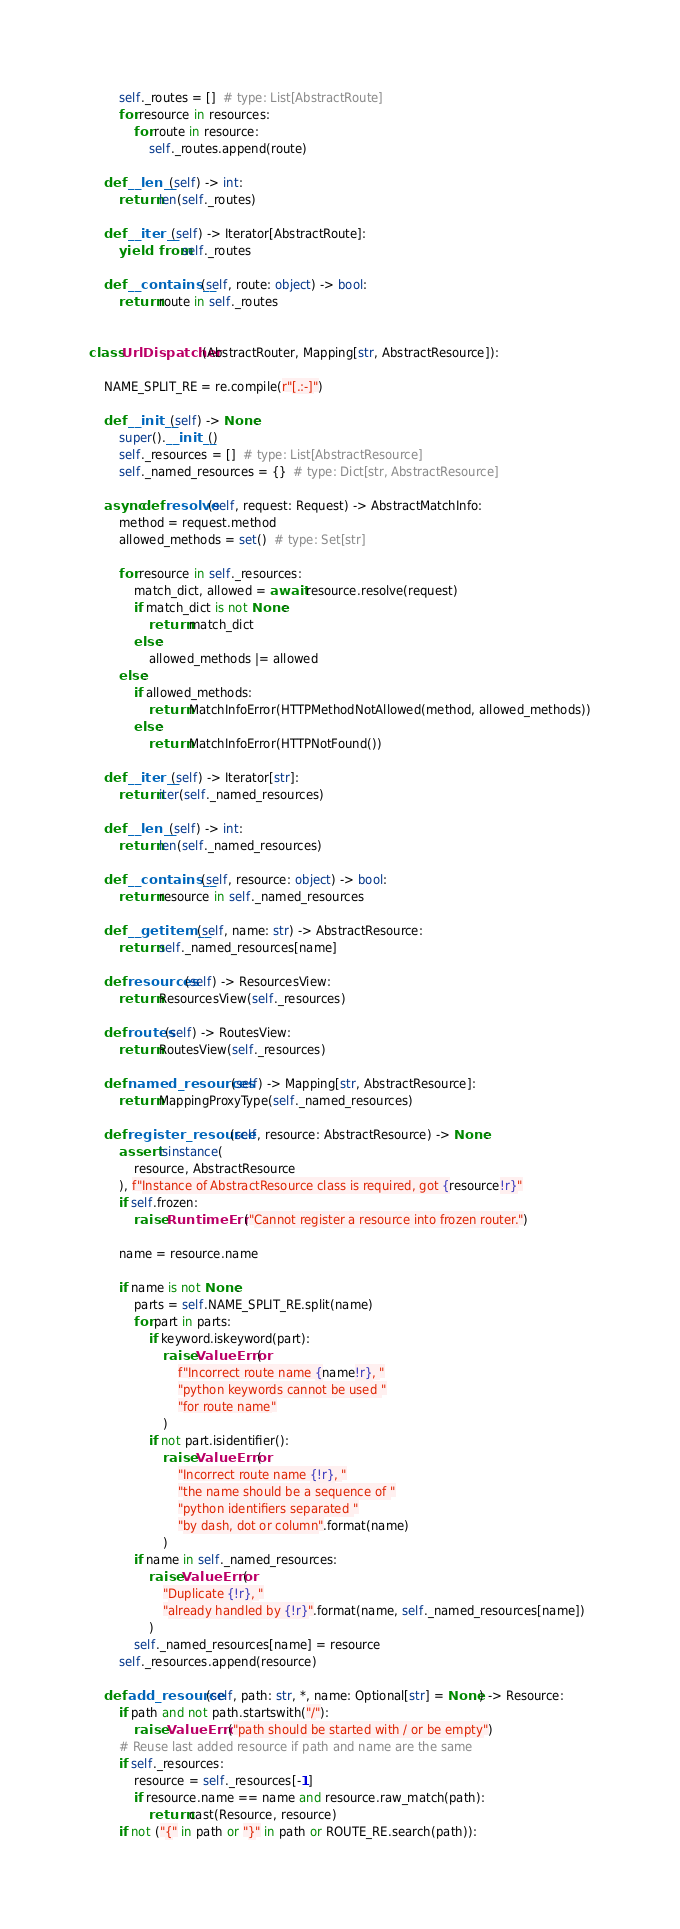Convert code to text. <code><loc_0><loc_0><loc_500><loc_500><_Python_>        self._routes = []  # type: List[AbstractRoute]
        for resource in resources:
            for route in resource:
                self._routes.append(route)

    def __len__(self) -> int:
        return len(self._routes)

    def __iter__(self) -> Iterator[AbstractRoute]:
        yield from self._routes

    def __contains__(self, route: object) -> bool:
        return route in self._routes


class UrlDispatcher(AbstractRouter, Mapping[str, AbstractResource]):

    NAME_SPLIT_RE = re.compile(r"[.:-]")

    def __init__(self) -> None:
        super().__init__()
        self._resources = []  # type: List[AbstractResource]
        self._named_resources = {}  # type: Dict[str, AbstractResource]

    async def resolve(self, request: Request) -> AbstractMatchInfo:
        method = request.method
        allowed_methods = set()  # type: Set[str]

        for resource in self._resources:
            match_dict, allowed = await resource.resolve(request)
            if match_dict is not None:
                return match_dict
            else:
                allowed_methods |= allowed
        else:
            if allowed_methods:
                return MatchInfoError(HTTPMethodNotAllowed(method, allowed_methods))
            else:
                return MatchInfoError(HTTPNotFound())

    def __iter__(self) -> Iterator[str]:
        return iter(self._named_resources)

    def __len__(self) -> int:
        return len(self._named_resources)

    def __contains__(self, resource: object) -> bool:
        return resource in self._named_resources

    def __getitem__(self, name: str) -> AbstractResource:
        return self._named_resources[name]

    def resources(self) -> ResourcesView:
        return ResourcesView(self._resources)

    def routes(self) -> RoutesView:
        return RoutesView(self._resources)

    def named_resources(self) -> Mapping[str, AbstractResource]:
        return MappingProxyType(self._named_resources)

    def register_resource(self, resource: AbstractResource) -> None:
        assert isinstance(
            resource, AbstractResource
        ), f"Instance of AbstractResource class is required, got {resource!r}"
        if self.frozen:
            raise RuntimeError("Cannot register a resource into frozen router.")

        name = resource.name

        if name is not None:
            parts = self.NAME_SPLIT_RE.split(name)
            for part in parts:
                if keyword.iskeyword(part):
                    raise ValueError(
                        f"Incorrect route name {name!r}, "
                        "python keywords cannot be used "
                        "for route name"
                    )
                if not part.isidentifier():
                    raise ValueError(
                        "Incorrect route name {!r}, "
                        "the name should be a sequence of "
                        "python identifiers separated "
                        "by dash, dot or column".format(name)
                    )
            if name in self._named_resources:
                raise ValueError(
                    "Duplicate {!r}, "
                    "already handled by {!r}".format(name, self._named_resources[name])
                )
            self._named_resources[name] = resource
        self._resources.append(resource)

    def add_resource(self, path: str, *, name: Optional[str] = None) -> Resource:
        if path and not path.startswith("/"):
            raise ValueError("path should be started with / or be empty")
        # Reuse last added resource if path and name are the same
        if self._resources:
            resource = self._resources[-1]
            if resource.name == name and resource.raw_match(path):
                return cast(Resource, resource)
        if not ("{" in path or "}" in path or ROUTE_RE.search(path)):</code> 